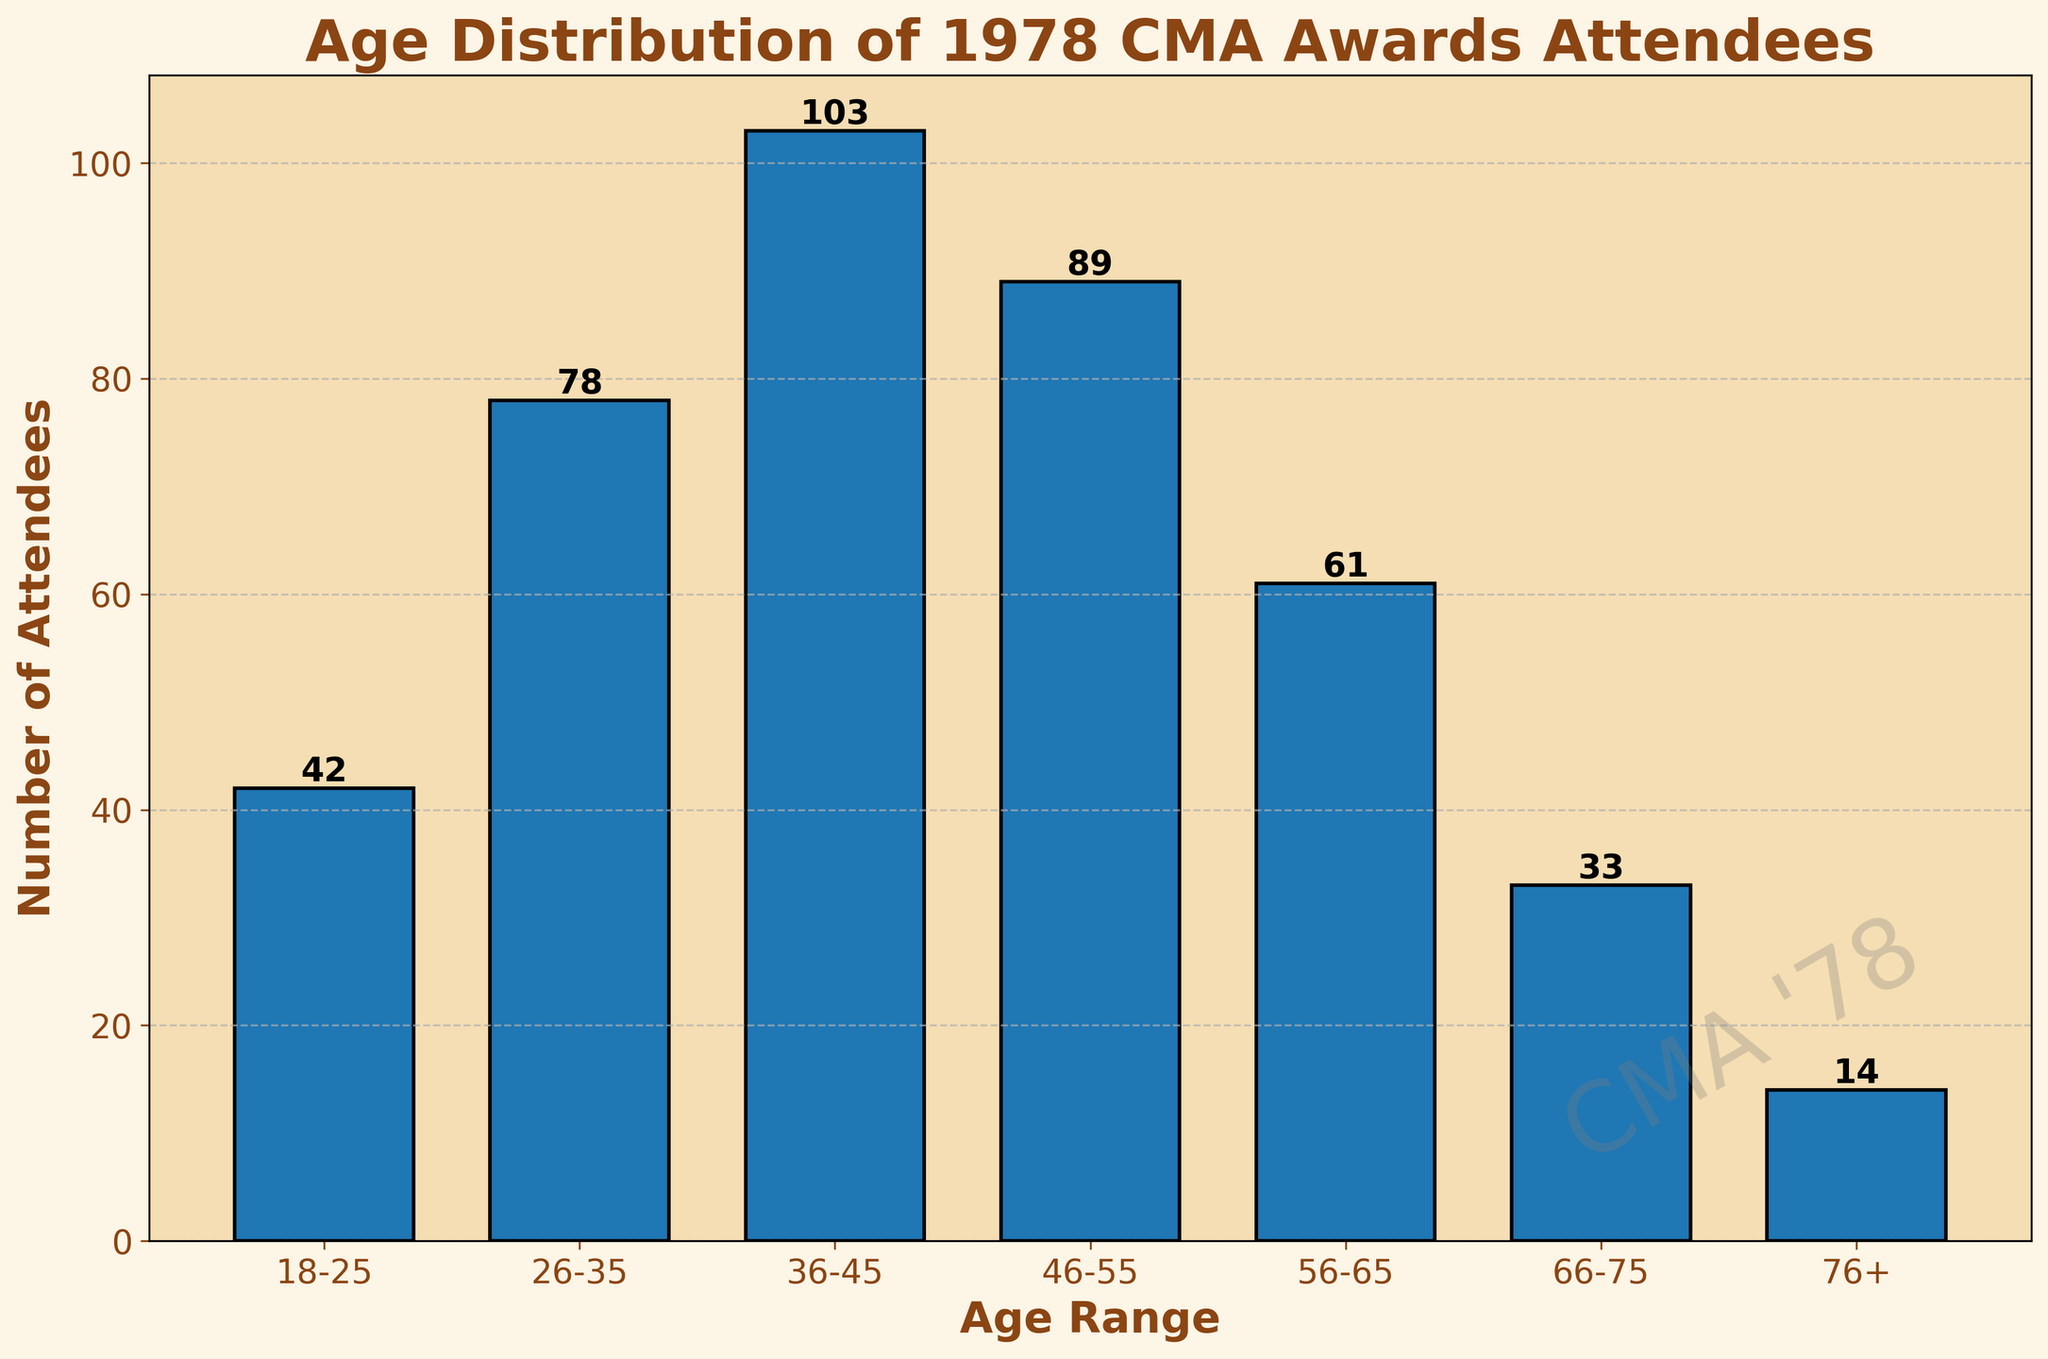What is the title of the plot? The title is displayed at the top of the plot, indicating what the histogram represents.
Answer: Age Distribution of 1978 CMA Awards Attendees Which age range has the highest number of attendees? Look for the tallest bar in the histogram, which indicates the highest number. The age range below this bar is the answer.
Answer: 36-45 How many attendees are in the 56-65 age range? This information is directly shown by the height of the bar under the 56-65 age range.
Answer: 61 What is the total number of attendees in the age ranges 18-25 and 26-35? Add the number of attendees from the 18-25 and 26-35 age ranges. 42 (18-25) + 78 (26-35) = 120.
Answer: 120 Which age range has the fewest attendees? Look for the shortest bar in the histogram, which indicates the lowest number. The age range below this bar is the answer.
Answer: 76+ What is the difference in the number of attendees between the 36-45 and 46-55 age ranges? Subtract the number of attendees in the 46-55 age range from those in the 36-45 age range. 103 (36-45) - 89 (46-55) = 14.
Answer: 14 What is the average number of attendees across all age ranges? Calculate the average by summing all the attendees and dividing by the number of age ranges: (42 + 78 + 103 + 89 + 61 + 33 + 14) / 7 = 60.
Answer: 60 How does the number of attendees in the 66-75 age range compare to those in the 76+ age range? Compare the heights of the bars for the 66-75 and 76+ age ranges. 33 (66-75) is greater than 14 (76+).
Answer: 66-75 has more What is the total number of attendees at the 1978 CMA Awards based on the data provided? Add the number of attendees from all age ranges: 42 + 78 + 103 + 89 + 61 + 33 + 14 = 420.
Answer: 420 